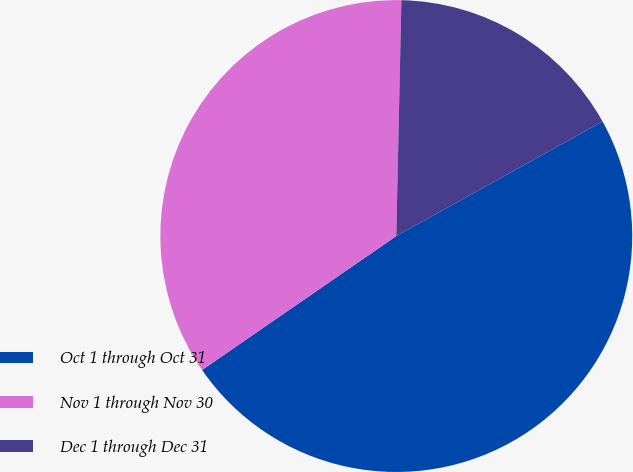Convert chart to OTSL. <chart><loc_0><loc_0><loc_500><loc_500><pie_chart><fcel>Oct 1 through Oct 31<fcel>Nov 1 through Nov 30<fcel>Dec 1 through Dec 31<nl><fcel>48.46%<fcel>34.95%<fcel>16.59%<nl></chart> 